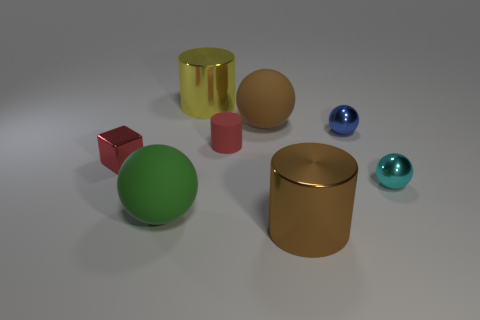Add 1 tiny metal cubes. How many objects exist? 9 Subtract all gray spheres. Subtract all cyan blocks. How many spheres are left? 4 Subtract all cylinders. How many objects are left? 5 Add 8 shiny cylinders. How many shiny cylinders exist? 10 Subtract 1 brown cylinders. How many objects are left? 7 Subtract all brown shiny objects. Subtract all big brown metal cylinders. How many objects are left? 6 Add 7 small blue things. How many small blue things are left? 8 